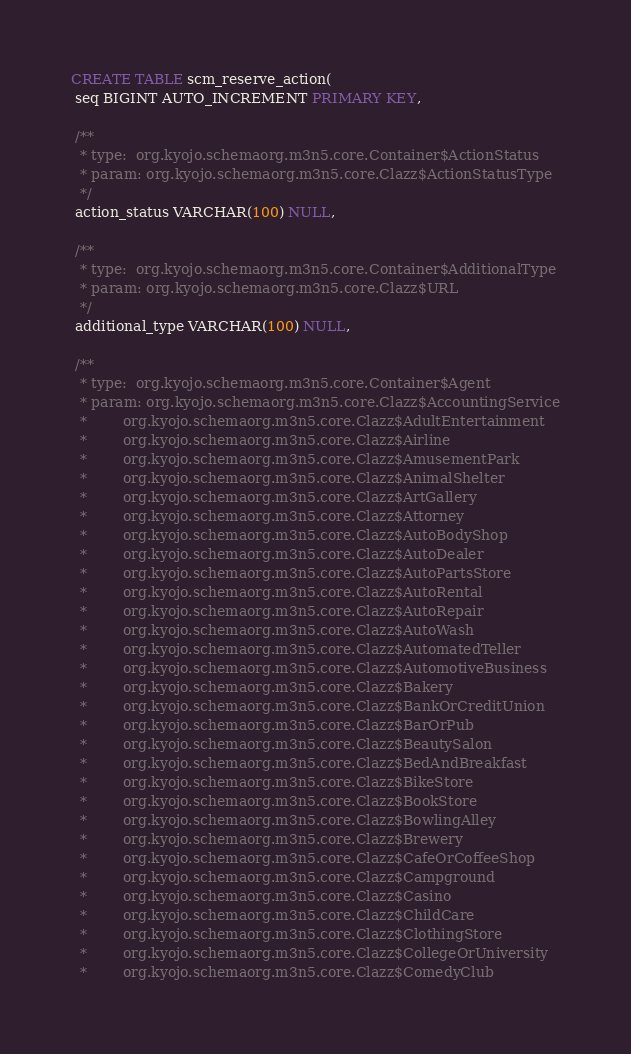Convert code to text. <code><loc_0><loc_0><loc_500><loc_500><_SQL_>CREATE TABLE scm_reserve_action(
 seq BIGINT AUTO_INCREMENT PRIMARY KEY,

 /**
  * type:  org.kyojo.schemaorg.m3n5.core.Container$ActionStatus
  * param: org.kyojo.schemaorg.m3n5.core.Clazz$ActionStatusType
  */
 action_status VARCHAR(100) NULL,

 /**
  * type:  org.kyojo.schemaorg.m3n5.core.Container$AdditionalType
  * param: org.kyojo.schemaorg.m3n5.core.Clazz$URL
  */
 additional_type VARCHAR(100) NULL,

 /**
  * type:  org.kyojo.schemaorg.m3n5.core.Container$Agent
  * param: org.kyojo.schemaorg.m3n5.core.Clazz$AccountingService
  *        org.kyojo.schemaorg.m3n5.core.Clazz$AdultEntertainment
  *        org.kyojo.schemaorg.m3n5.core.Clazz$Airline
  *        org.kyojo.schemaorg.m3n5.core.Clazz$AmusementPark
  *        org.kyojo.schemaorg.m3n5.core.Clazz$AnimalShelter
  *        org.kyojo.schemaorg.m3n5.core.Clazz$ArtGallery
  *        org.kyojo.schemaorg.m3n5.core.Clazz$Attorney
  *        org.kyojo.schemaorg.m3n5.core.Clazz$AutoBodyShop
  *        org.kyojo.schemaorg.m3n5.core.Clazz$AutoDealer
  *        org.kyojo.schemaorg.m3n5.core.Clazz$AutoPartsStore
  *        org.kyojo.schemaorg.m3n5.core.Clazz$AutoRental
  *        org.kyojo.schemaorg.m3n5.core.Clazz$AutoRepair
  *        org.kyojo.schemaorg.m3n5.core.Clazz$AutoWash
  *        org.kyojo.schemaorg.m3n5.core.Clazz$AutomatedTeller
  *        org.kyojo.schemaorg.m3n5.core.Clazz$AutomotiveBusiness
  *        org.kyojo.schemaorg.m3n5.core.Clazz$Bakery
  *        org.kyojo.schemaorg.m3n5.core.Clazz$BankOrCreditUnion
  *        org.kyojo.schemaorg.m3n5.core.Clazz$BarOrPub
  *        org.kyojo.schemaorg.m3n5.core.Clazz$BeautySalon
  *        org.kyojo.schemaorg.m3n5.core.Clazz$BedAndBreakfast
  *        org.kyojo.schemaorg.m3n5.core.Clazz$BikeStore
  *        org.kyojo.schemaorg.m3n5.core.Clazz$BookStore
  *        org.kyojo.schemaorg.m3n5.core.Clazz$BowlingAlley
  *        org.kyojo.schemaorg.m3n5.core.Clazz$Brewery
  *        org.kyojo.schemaorg.m3n5.core.Clazz$CafeOrCoffeeShop
  *        org.kyojo.schemaorg.m3n5.core.Clazz$Campground
  *        org.kyojo.schemaorg.m3n5.core.Clazz$Casino
  *        org.kyojo.schemaorg.m3n5.core.Clazz$ChildCare
  *        org.kyojo.schemaorg.m3n5.core.Clazz$ClothingStore
  *        org.kyojo.schemaorg.m3n5.core.Clazz$CollegeOrUniversity
  *        org.kyojo.schemaorg.m3n5.core.Clazz$ComedyClub</code> 